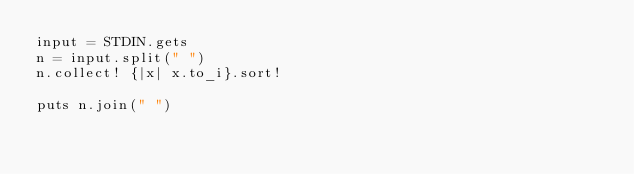Convert code to text. <code><loc_0><loc_0><loc_500><loc_500><_Ruby_>input = STDIN.gets
n = input.split(" ")
n.collect! {|x| x.to_i}.sort!

puts n.join(" ")</code> 